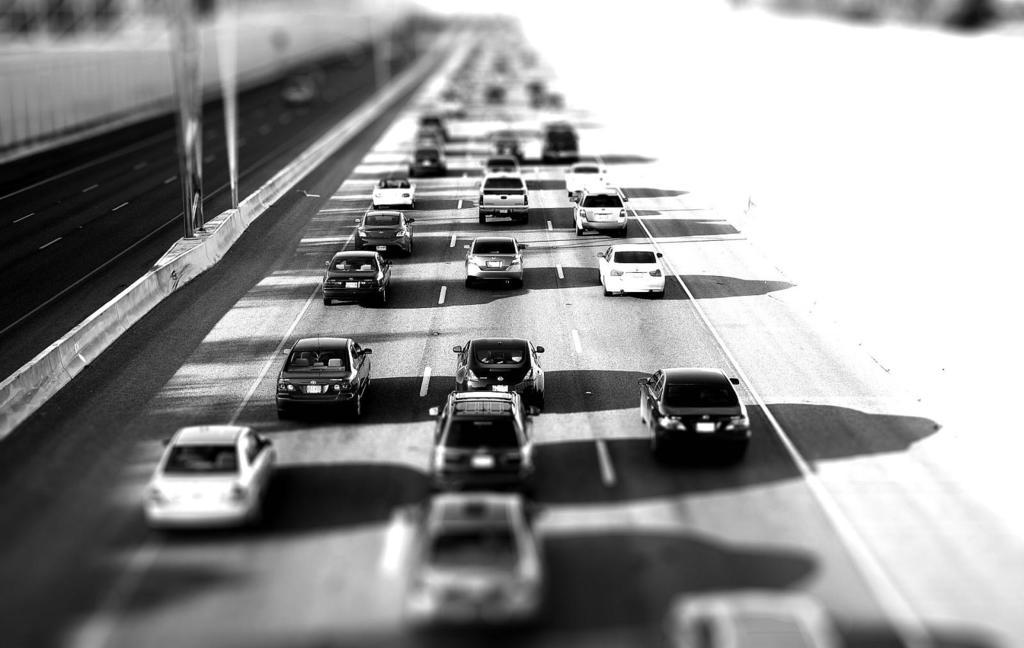What is the color scheme of the image? The image is black and white. What type of infrastructure can be seen in the image? There are roads in the image. What vehicles are present in the image? There are cars in the image. What objects are standing upright in the image? There are poles in the image. How would you describe the background of the image? The background of the image is blurred. Can you tell me where the store is located in the image? There is no store present in the image. What type of yoke can be seen attached to the yak in the image? There is no yoke or yak present in the image. 